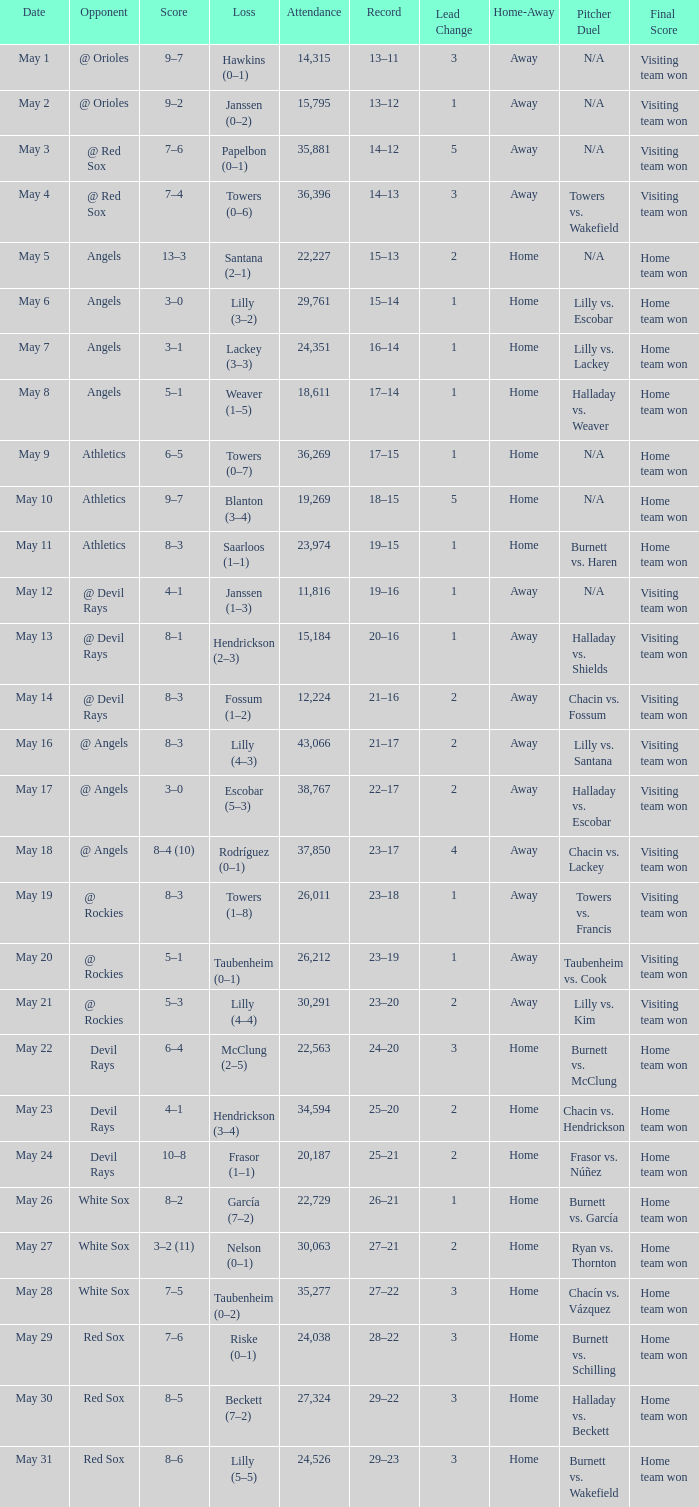When the team had their record of 16–14, what was the total attendance? 1.0. Could you parse the entire table as a dict? {'header': ['Date', 'Opponent', 'Score', 'Loss', 'Attendance', 'Record', 'Lead Change', 'Home-Away', 'Pitcher Duel', 'Final Score'], 'rows': [['May 1', '@ Orioles', '9–7', 'Hawkins (0–1)', '14,315', '13–11', '3', 'Away', 'N/A', 'Visiting team won'], ['May 2', '@ Orioles', '9–2', 'Janssen (0–2)', '15,795', '13–12', '1', 'Away', 'N/A', 'Visiting team won'], ['May 3', '@ Red Sox', '7–6', 'Papelbon (0–1)', '35,881', '14–12', '5', 'Away', 'N/A', 'Visiting team won'], ['May 4', '@ Red Sox', '7–4', 'Towers (0–6)', '36,396', '14–13', '3', 'Away', 'Towers vs. Wakefield', 'Visiting team won'], ['May 5', 'Angels', '13–3', 'Santana (2–1)', '22,227', '15–13', '2', 'Home', 'N/A', 'Home team won'], ['May 6', 'Angels', '3–0', 'Lilly (3–2)', '29,761', '15–14', '1', 'Home', 'Lilly vs. Escobar', 'Home team won'], ['May 7', 'Angels', '3–1', 'Lackey (3–3)', '24,351', '16–14', '1', 'Home', 'Lilly vs. Lackey', 'Home team won'], ['May 8', 'Angels', '5–1', 'Weaver (1–5)', '18,611', '17–14', '1', 'Home', 'Halladay vs. Weaver', 'Home team won'], ['May 9', 'Athletics', '6–5', 'Towers (0–7)', '36,269', '17–15', '1', 'Home', 'N/A', 'Home team won'], ['May 10', 'Athletics', '9–7', 'Blanton (3–4)', '19,269', '18–15', '5', 'Home', 'N/A', 'Home team won'], ['May 11', 'Athletics', '8–3', 'Saarloos (1–1)', '23,974', '19–15', '1', 'Home', 'Burnett vs. Haren', 'Home team won'], ['May 12', '@ Devil Rays', '4–1', 'Janssen (1–3)', '11,816', '19–16', '1', 'Away', 'N/A', 'Visiting team won'], ['May 13', '@ Devil Rays', '8–1', 'Hendrickson (2–3)', '15,184', '20–16', '1', 'Away', 'Halladay vs. Shields', 'Visiting team won'], ['May 14', '@ Devil Rays', '8–3', 'Fossum (1–2)', '12,224', '21–16', '2', 'Away', 'Chacin vs. Fossum', 'Visiting team won'], ['May 16', '@ Angels', '8–3', 'Lilly (4–3)', '43,066', '21–17', '2', 'Away', 'Lilly vs. Santana', 'Visiting team won'], ['May 17', '@ Angels', '3–0', 'Escobar (5–3)', '38,767', '22–17', '2', 'Away', 'Halladay vs. Escobar', 'Visiting team won'], ['May 18', '@ Angels', '8–4 (10)', 'Rodríguez (0–1)', '37,850', '23–17', '4', 'Away', 'Chacin vs. Lackey', 'Visiting team won'], ['May 19', '@ Rockies', '8–3', 'Towers (1–8)', '26,011', '23–18', '1', 'Away', 'Towers vs. Francis', 'Visiting team won'], ['May 20', '@ Rockies', '5–1', 'Taubenheim (0–1)', '26,212', '23–19', '1', 'Away', 'Taubenheim vs. Cook', 'Visiting team won'], ['May 21', '@ Rockies', '5–3', 'Lilly (4–4)', '30,291', '23–20', '2', 'Away', 'Lilly vs. Kim', 'Visiting team won'], ['May 22', 'Devil Rays', '6–4', 'McClung (2–5)', '22,563', '24–20', '3', 'Home', 'Burnett vs. McClung', 'Home team won'], ['May 23', 'Devil Rays', '4–1', 'Hendrickson (3–4)', '34,594', '25–20', '2', 'Home', 'Chacin vs. Hendrickson', 'Home team won'], ['May 24', 'Devil Rays', '10–8', 'Frasor (1–1)', '20,187', '25–21', '2', 'Home', 'Frasor vs. Núñez', 'Home team won'], ['May 26', 'White Sox', '8–2', 'García (7–2)', '22,729', '26–21', '1', 'Home', 'Burnett vs. García', 'Home team won'], ['May 27', 'White Sox', '3–2 (11)', 'Nelson (0–1)', '30,063', '27–21', '2', 'Home', 'Ryan vs. Thornton', 'Home team won'], ['May 28', 'White Sox', '7–5', 'Taubenheim (0–2)', '35,277', '27–22', '3', 'Home', 'Chacín vs. Vázquez', 'Home team won'], ['May 29', 'Red Sox', '7–6', 'Riske (0–1)', '24,038', '28–22', '3', 'Home', 'Burnett vs. Schilling', 'Home team won'], ['May 30', 'Red Sox', '8–5', 'Beckett (7–2)', '27,324', '29–22', '3', 'Home', 'Halladay vs. Beckett', 'Home team won'], ['May 31', 'Red Sox', '8–6', 'Lilly (5–5)', '24,526', '29–23', '3', 'Home', 'Burnett vs. Wakefield', 'Home team won']]} 